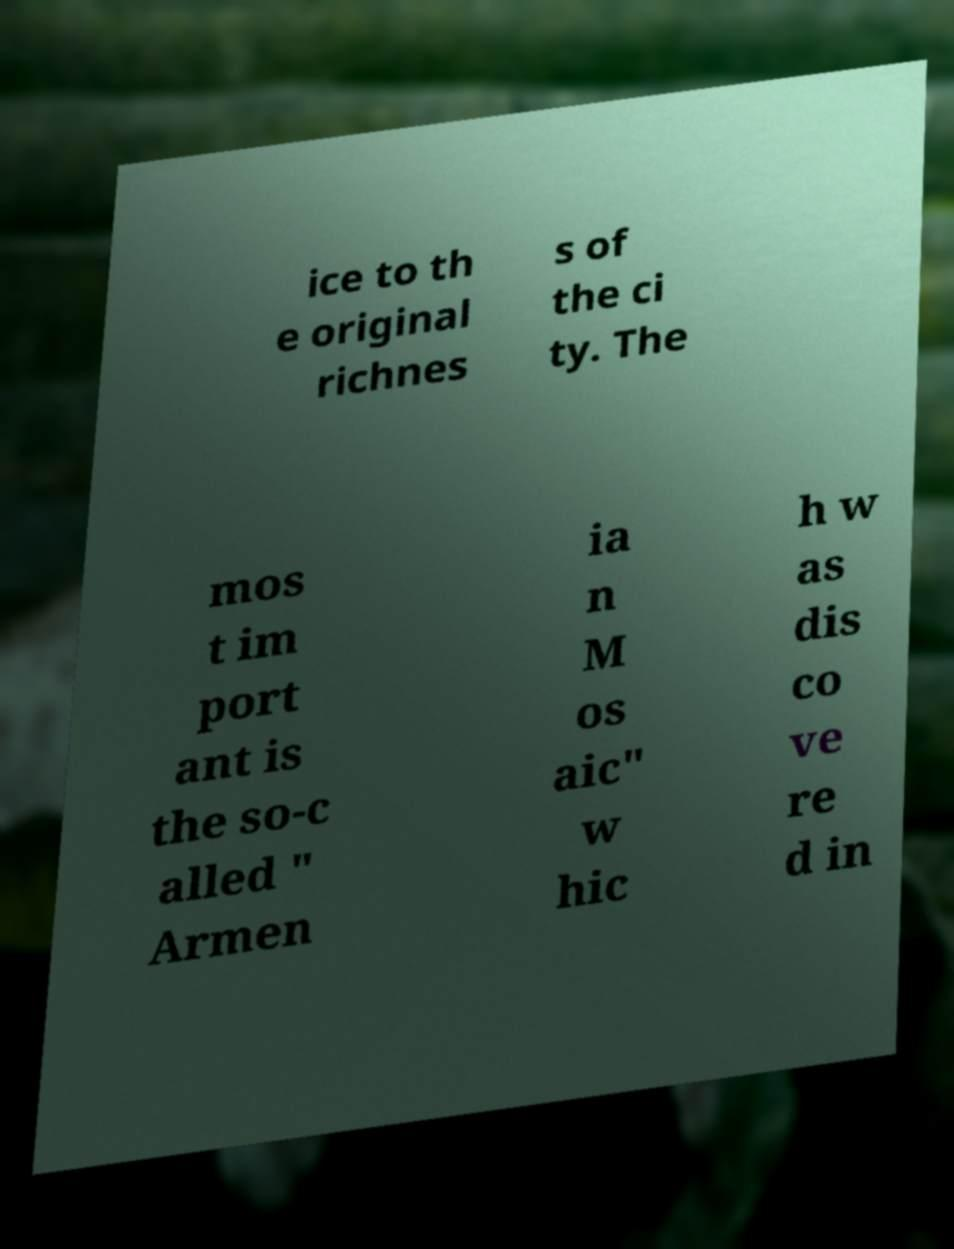Can you accurately transcribe the text from the provided image for me? ice to th e original richnes s of the ci ty. The mos t im port ant is the so-c alled " Armen ia n M os aic" w hic h w as dis co ve re d in 